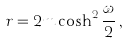Convert formula to latex. <formula><loc_0><loc_0><loc_500><loc_500>r = 2 m \cosh ^ { 2 } \frac { \omega } { 2 } \, ,</formula> 